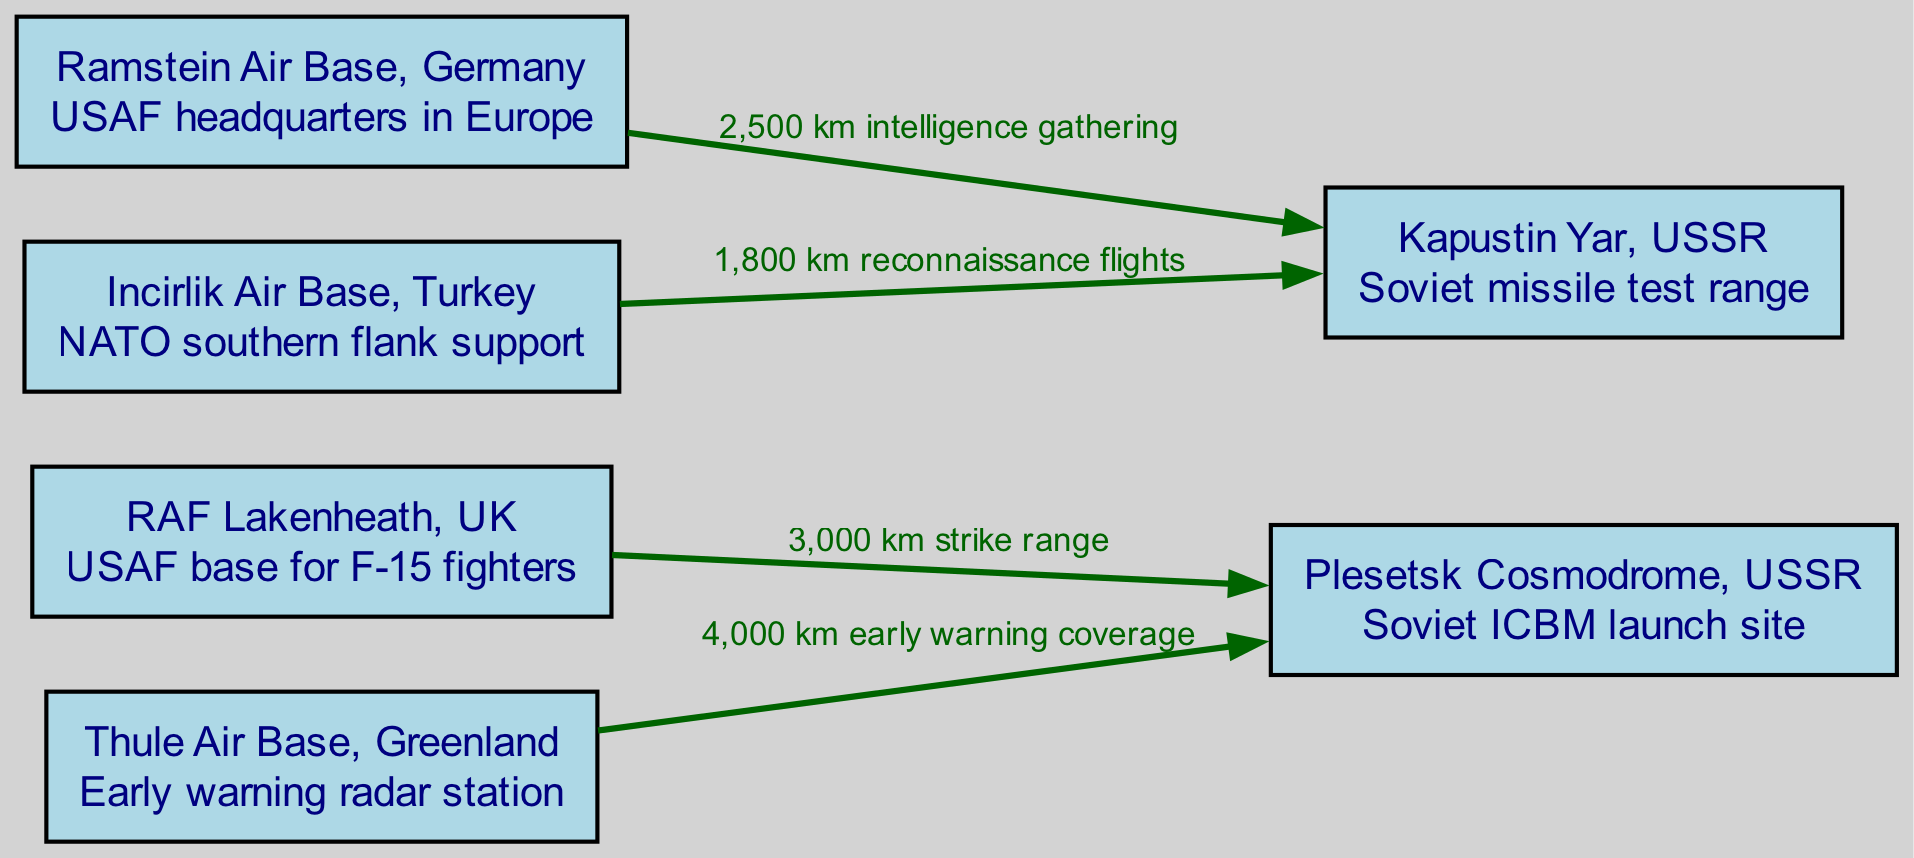What is the distance of the strike range from RAF Lakenheath to Plesetsk? The edge from RAF Lakenheath to Plesetsk indicates a strike range of 3,000 km. The label on the edge provides this specific information.
Answer: 3,000 km What type of aircraft is stationed at RAF Lakenheath? The description for RAF Lakenheath states it is a USAF base for F-15 fighters, which identifies the type of aircraft stationed there.
Answer: F-15 fighters How many nodes are present in this diagram? The diagram contains a total of six nodes, each representing a significant air base. Counting the listed nodes from the data confirms this number.
Answer: 6 What is the role of Thule Air Base? The description for Thule indicates it operates as an early warning radar station. This tells us the primary function of Thule in the context of military aviation.
Answer: Early warning radar station What is the range of reconnaissance flights from Incirlik to Kapustin Yar? The edge from Incirlik to Kapustin Yar specifies reconnaissance flights at a distance of 1,800 km. This clear labeling on the edge gives us the necessary information.
Answer: 1,800 km What base serves as the USAF headquarters in Europe? According to the provided information, Ramstein Air Base is designated as the USAF headquarters in Europe, which directly answers the question.
Answer: Ramstein Air Base What is the coverage distance for early warning from Thule to Plesetsk? The label between Thule and Plesetsk states a coverage of 4,000 km for early warning. This provides a direct answer to the distance required for early warning purposes.
Answer: 4,000 km Which air base supports NATO's southern flank? The description for Incirlik Air Base specifies that it supports NATO's southern flank. This identifies Incirlik's strategic importance in the context of NATO.
Answer: Incirlik Air Base How is Kapustin Yar primarily used according to the diagram? The description of Kapustin Yar reveals it is used as a Soviet missile test range, which elucidates its primary purpose.
Answer: Soviet missile test range 